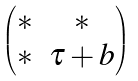<formula> <loc_0><loc_0><loc_500><loc_500>\begin{pmatrix} * & * \\ * & \tau + b \end{pmatrix}</formula> 